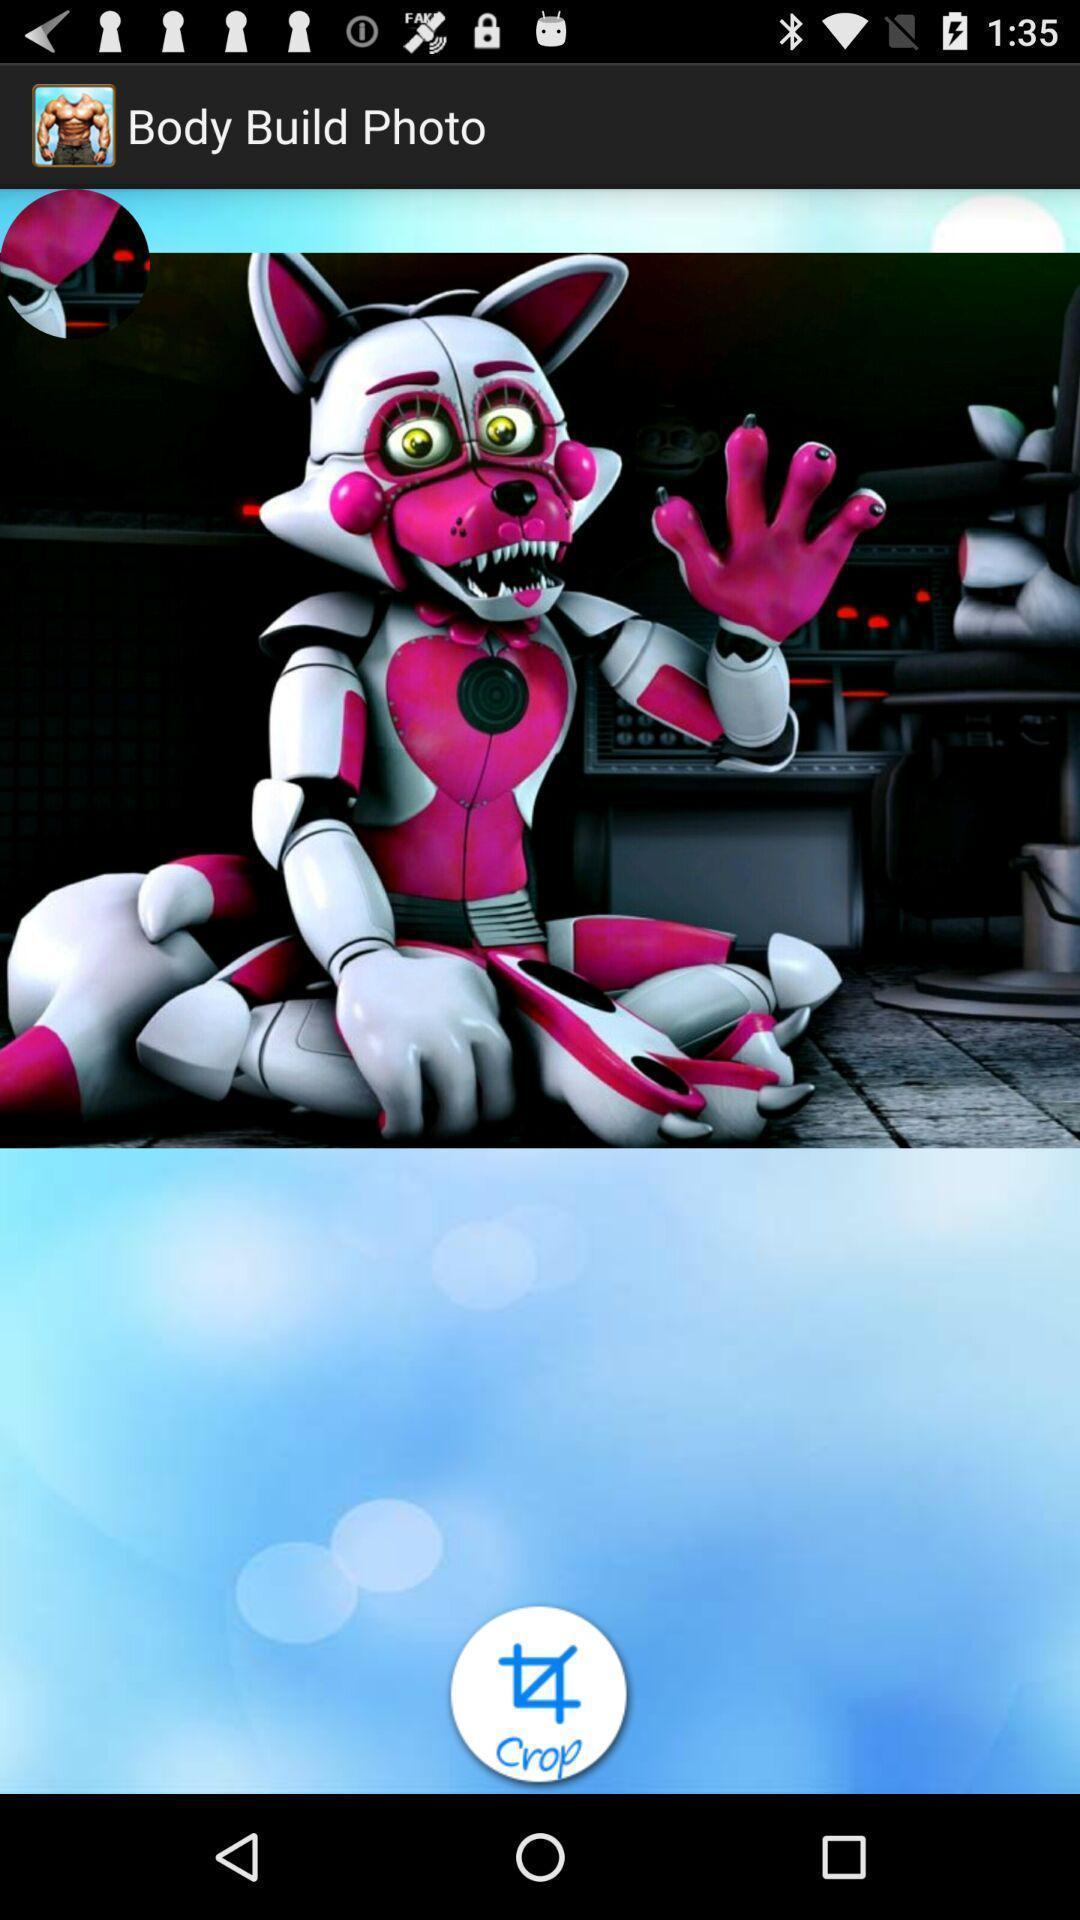Describe the content in this image. Page with body build suit photo. 